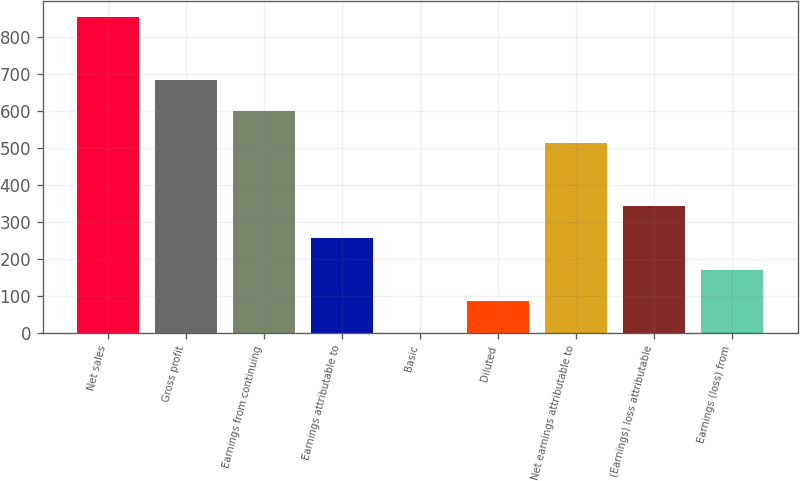Convert chart. <chart><loc_0><loc_0><loc_500><loc_500><bar_chart><fcel>Net sales<fcel>Gross profit<fcel>Earnings from continuing<fcel>Earnings attributable to<fcel>Basic<fcel>Diluted<fcel>Net earnings attributable to<fcel>(Earnings) loss attributable<fcel>Earnings (loss) from<nl><fcel>854.1<fcel>683.26<fcel>597.86<fcel>256.26<fcel>0.06<fcel>85.46<fcel>512.46<fcel>341.66<fcel>170.86<nl></chart> 